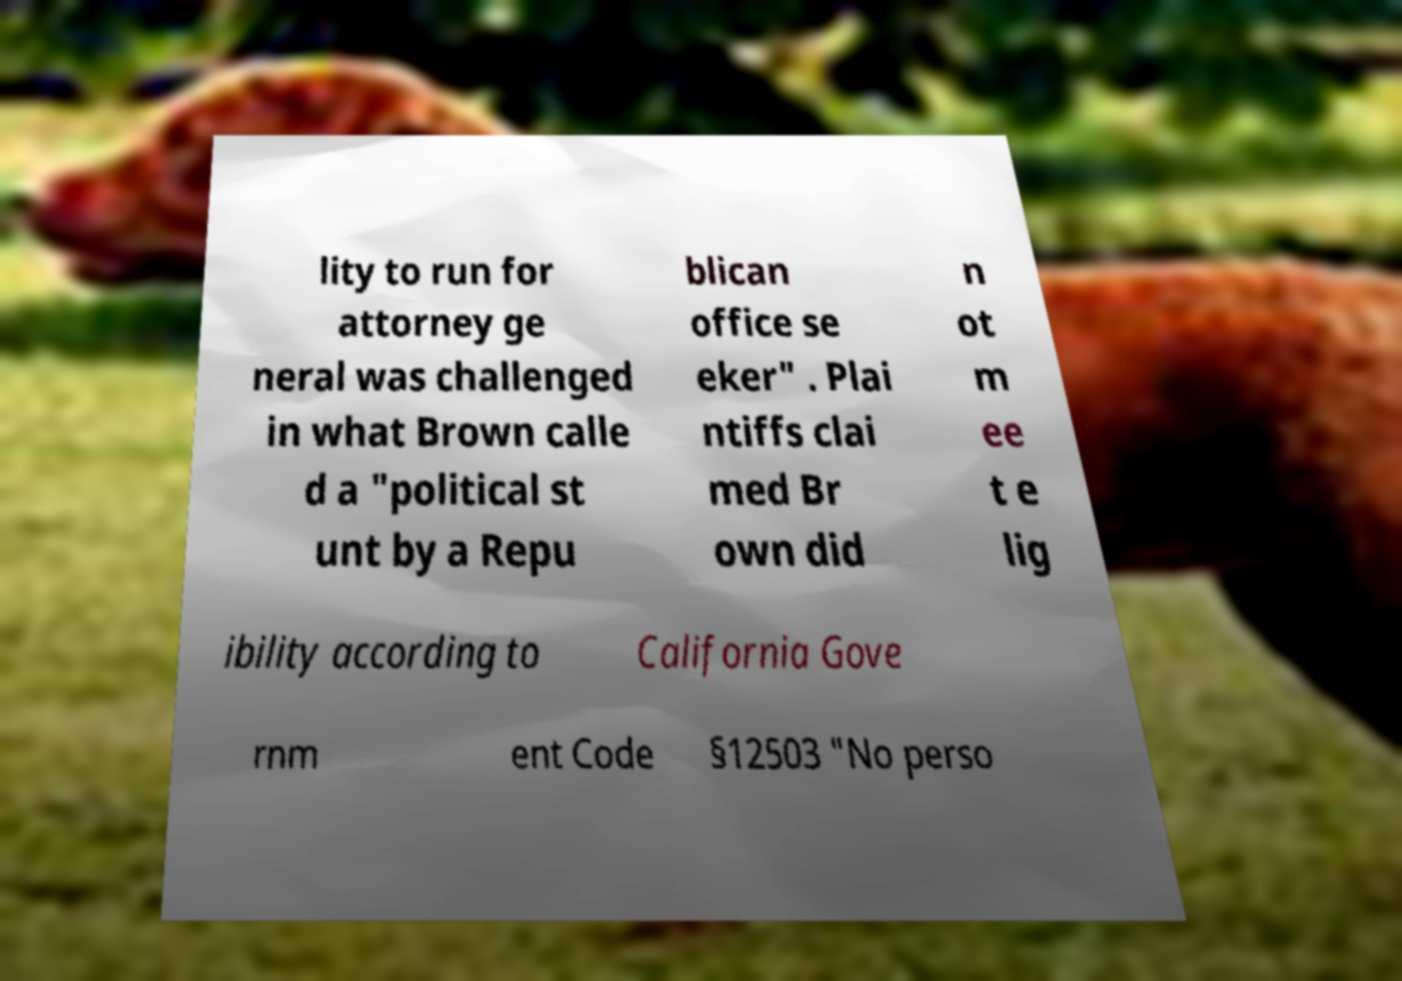Could you extract and type out the text from this image? lity to run for attorney ge neral was challenged in what Brown calle d a "political st unt by a Repu blican office se eker" . Plai ntiffs clai med Br own did n ot m ee t e lig ibility according to California Gove rnm ent Code §12503 "No perso 